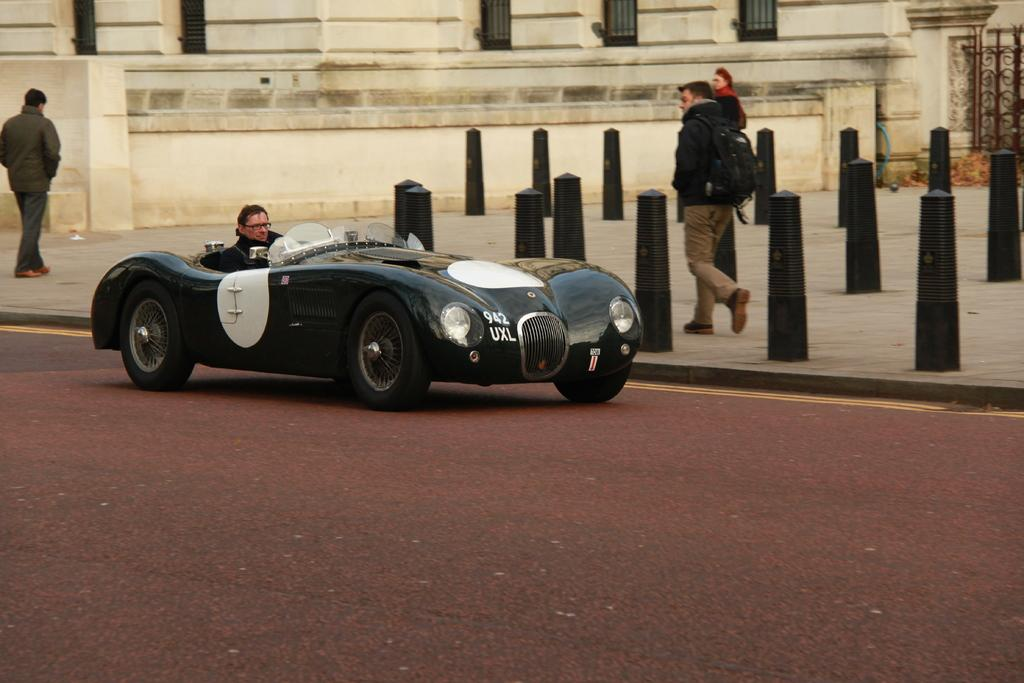What is the main subject of the image? There is a car in the image. Who or what is inside the car? A man is inside the car. What can be seen in the background of the image? There are people walking and a building in the background. Are there any other objects or structures visible in the background? Yes, there is a pole in the background. What type of cable can be seen connecting the car to the building in the image? There is no cable connecting the car to the building in the image. What impulse might have caused the man to enter the car in the image? The image does not provide any information about the man's motivation for entering the car, so we cannot determine the impulse that caused him to do so. 